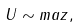Convert formula to latex. <formula><loc_0><loc_0><loc_500><loc_500>U \sim m a z ,</formula> 